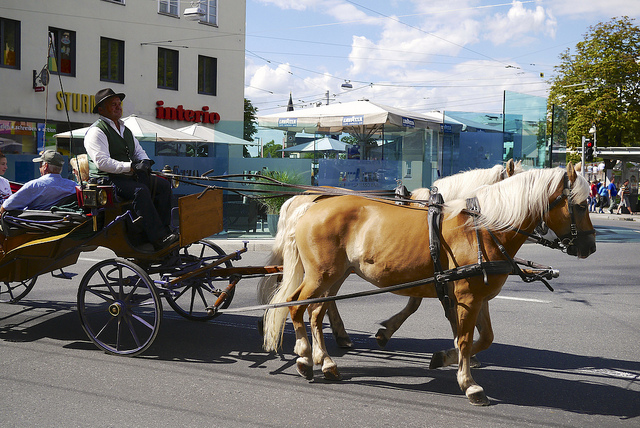Read and extract the text from this image. inturio STURN 